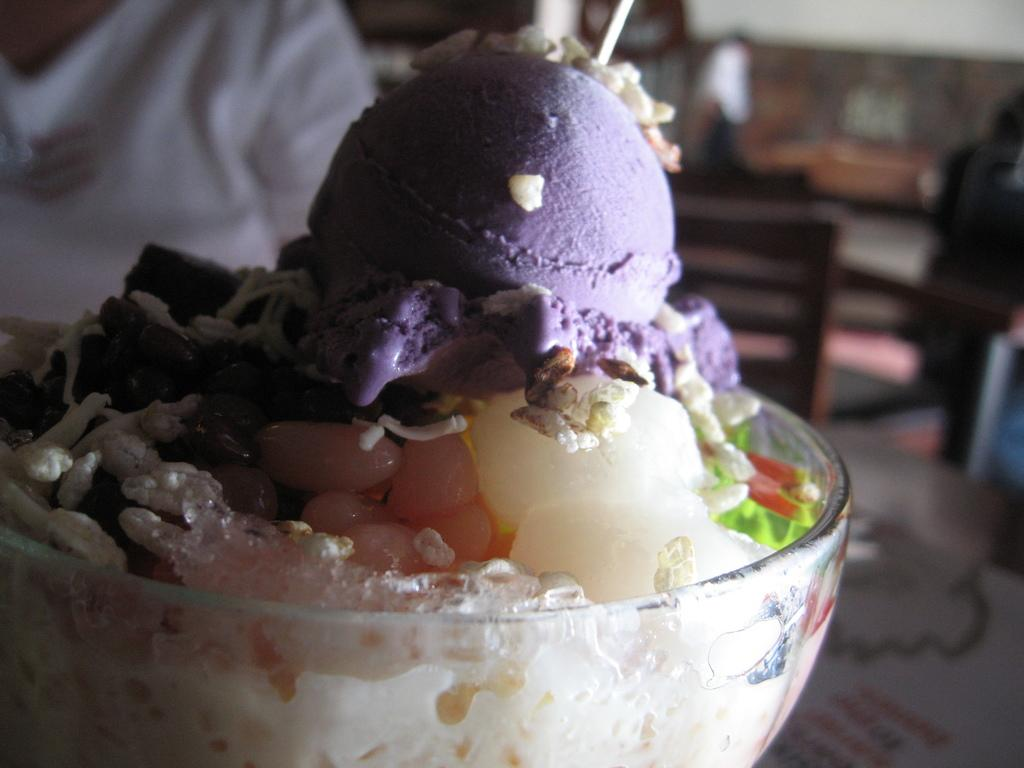What is in the bowl that is visible in the image? There is a dessert in a bowl in the image. Where is the bowl located in the image? The bowl is placed on a table. What else can be seen in the background of the image? There is a chair, another table, and a person in the background of the image. What is the tendency of the light bulb in the image? There is no light bulb present in the image. 